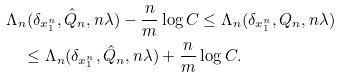<formula> <loc_0><loc_0><loc_500><loc_500>& \Lambda _ { n } ( \delta _ { x _ { 1 } ^ { n } } , \hat { Q } _ { n } , n \lambda ) - \frac { n } { m } \log C \leq \Lambda _ { n } ( \delta _ { x _ { 1 } ^ { n } } , Q _ { n } , n \lambda ) \\ & \quad \leq \Lambda _ { n } ( \delta _ { x _ { 1 } ^ { n } } , \hat { Q } _ { n } , n \lambda ) + \frac { n } { m } \log C .</formula> 